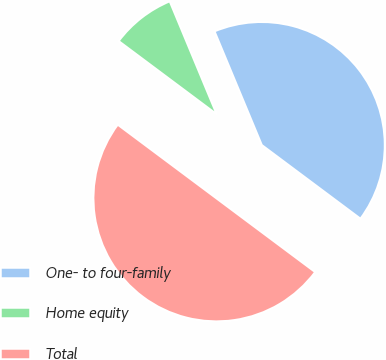<chart> <loc_0><loc_0><loc_500><loc_500><pie_chart><fcel>One- to four-family<fcel>Home equity<fcel>Total<nl><fcel>41.48%<fcel>8.52%<fcel>50.0%<nl></chart> 